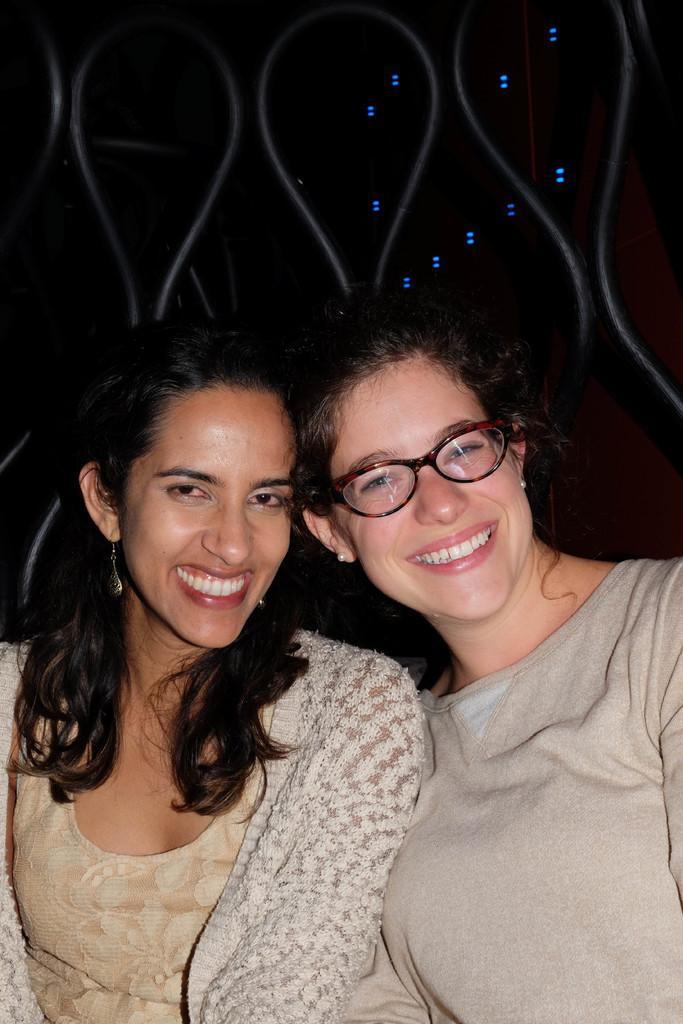Describe this image in one or two sentences. In the image there are two women in grey color dress smiling, behind them there is a railing. 